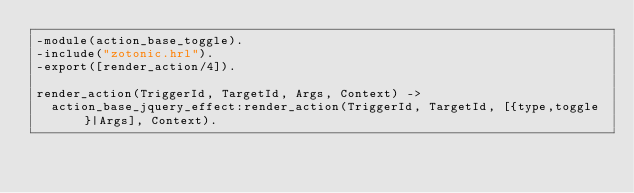<code> <loc_0><loc_0><loc_500><loc_500><_Erlang_>-module(action_base_toggle).
-include("zotonic.hrl").
-export([render_action/4]).

render_action(TriggerId, TargetId, Args, Context) ->
	action_base_jquery_effect:render_action(TriggerId, TargetId, [{type,toggle}|Args], Context).
</code> 